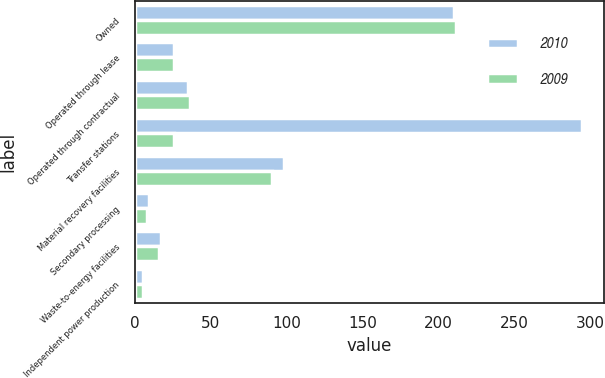<chart> <loc_0><loc_0><loc_500><loc_500><stacked_bar_chart><ecel><fcel>Owned<fcel>Operated through lease<fcel>Operated through contractual<fcel>Transfer stations<fcel>Material recovery facilities<fcel>Secondary processing<fcel>Waste-to-energy facilities<fcel>Independent power production<nl><fcel>2010<fcel>210<fcel>26<fcel>35<fcel>294<fcel>98<fcel>9<fcel>17<fcel>5<nl><fcel>2009<fcel>211<fcel>26<fcel>36<fcel>26<fcel>90<fcel>8<fcel>16<fcel>5<nl></chart> 